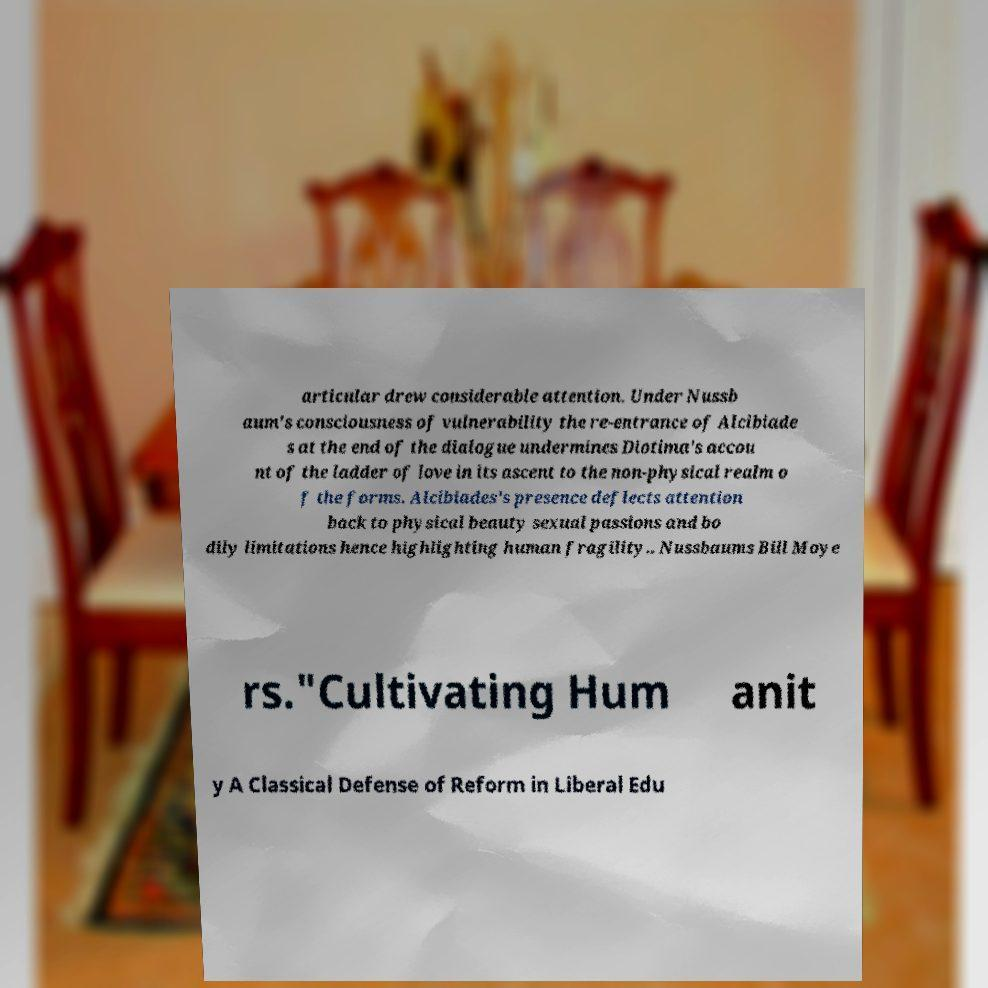Please identify and transcribe the text found in this image. articular drew considerable attention. Under Nussb aum's consciousness of vulnerability the re-entrance of Alcibiade s at the end of the dialogue undermines Diotima's accou nt of the ladder of love in its ascent to the non-physical realm o f the forms. Alcibiades's presence deflects attention back to physical beauty sexual passions and bo dily limitations hence highlighting human fragility.. Nussbaums Bill Moye rs."Cultivating Hum anit y A Classical Defense of Reform in Liberal Edu 